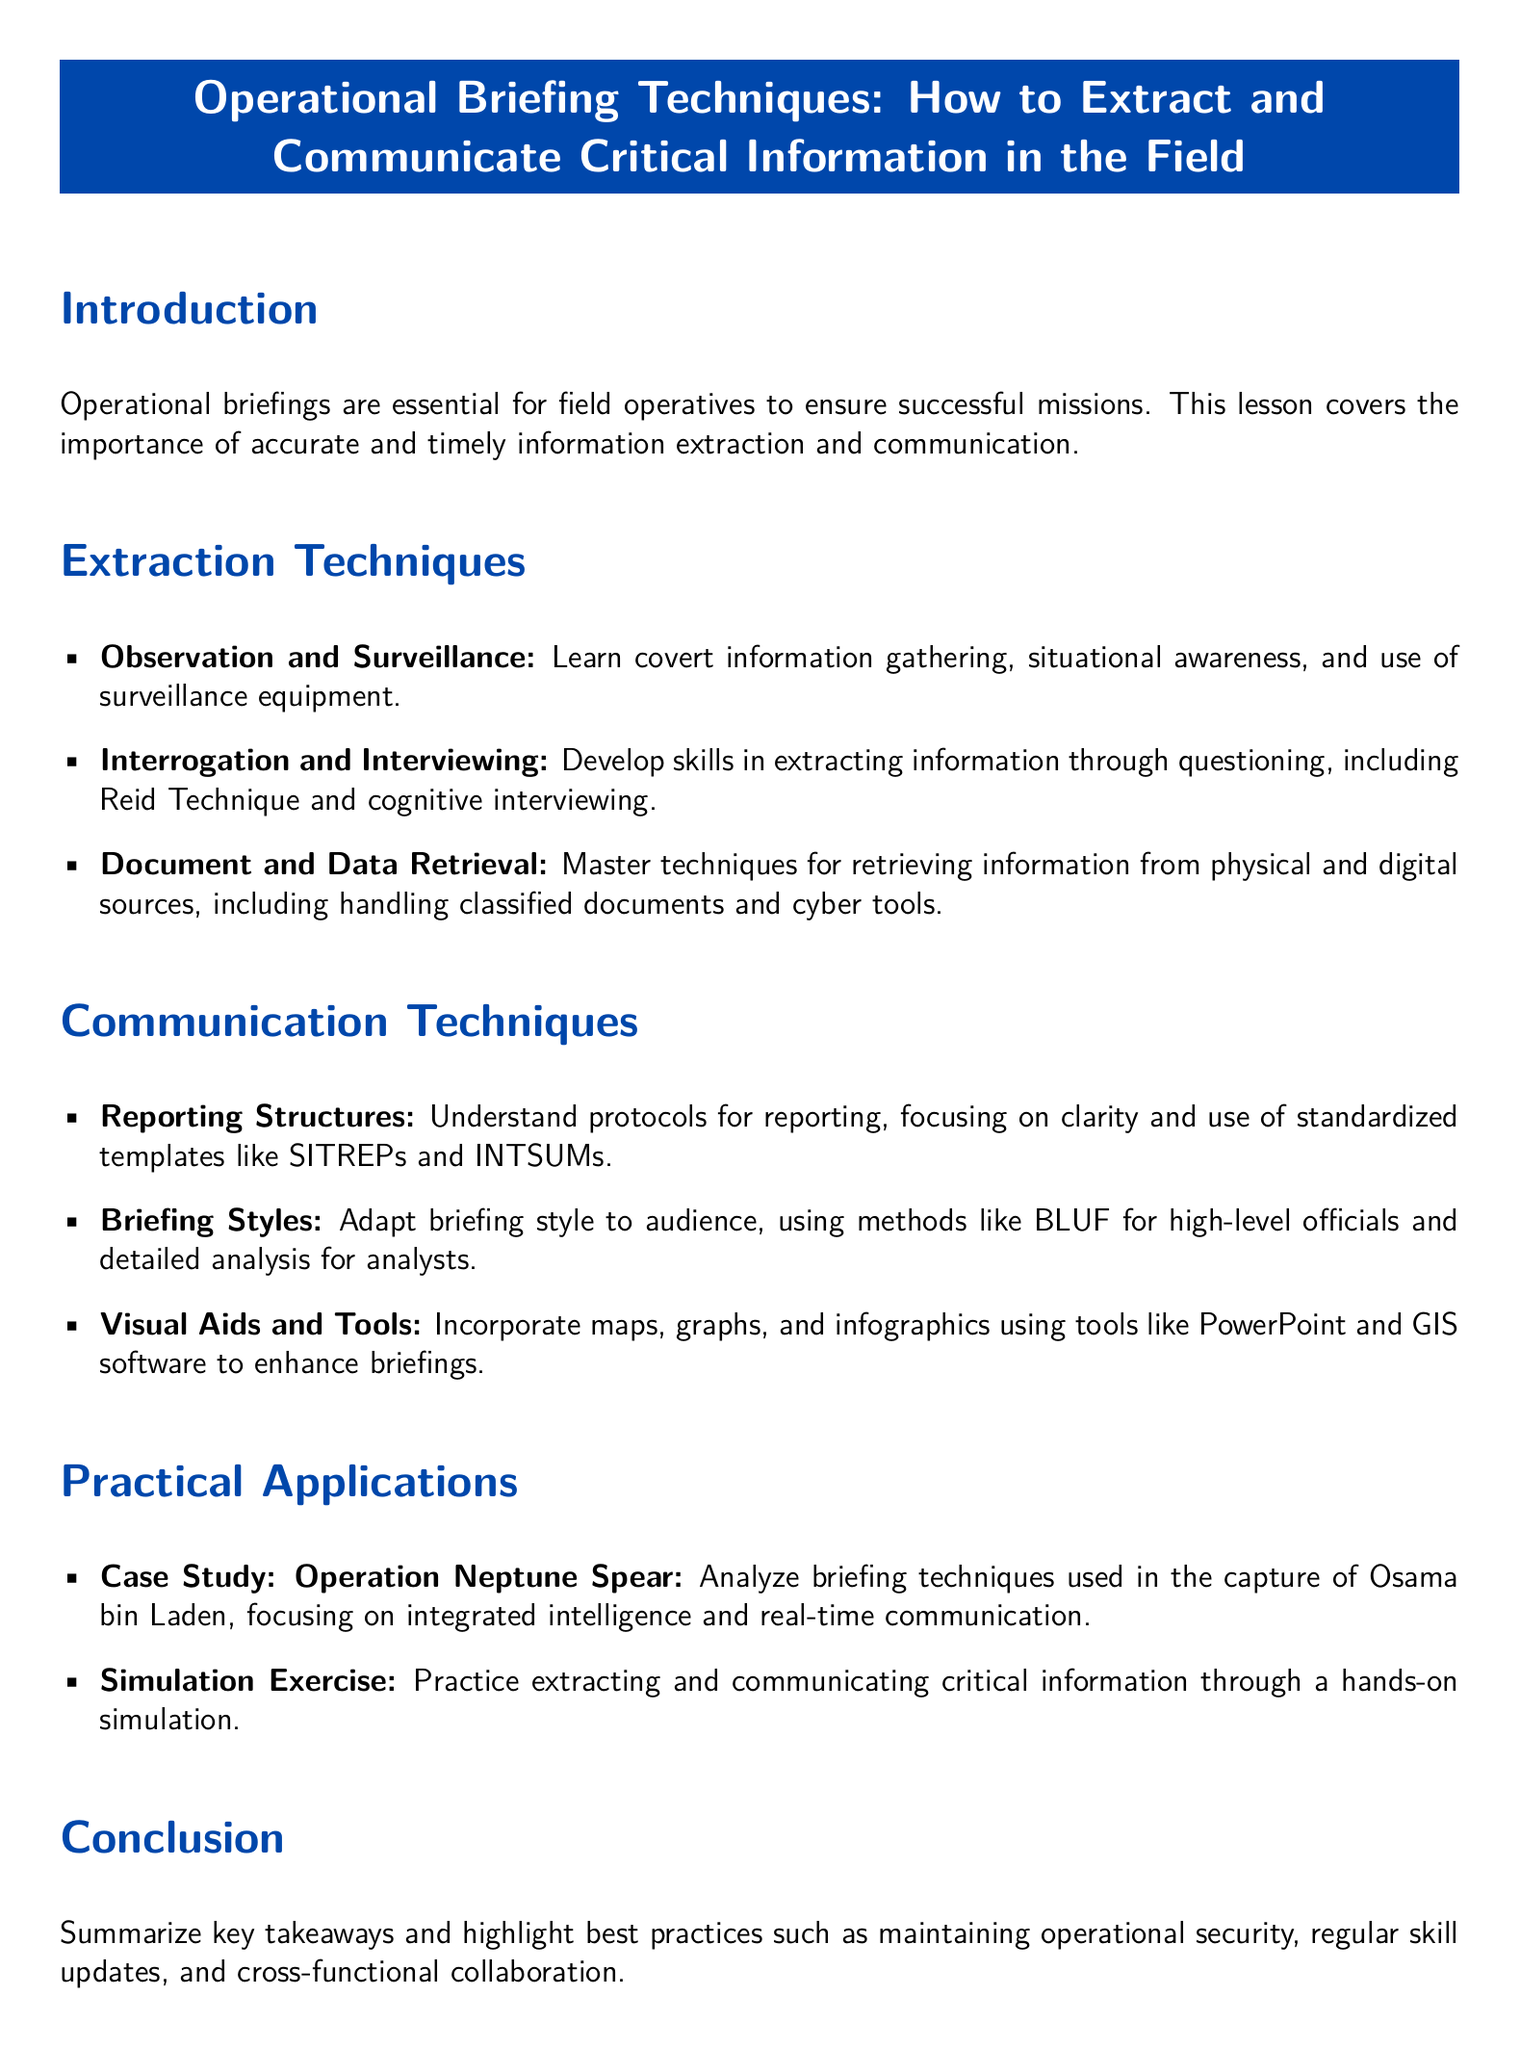What is the topic of the lesson plan? The topic of the lesson plan is clearly stated at the beginning of the document, which focuses on operational briefing techniques.
Answer: Operational Briefing Techniques: How to Extract and Communicate Critical Information in the Field What technique involves covert information gathering? This information can be found under the "Extraction Techniques" section, specifically listed as a bullet point.
Answer: Observation and Surveillance Which interviewing technique is mentioned in the document? The document lists specific techniques under "Interrogation and Interviewing," highlighting one of them explicitly.
Answer: Reid Technique What is the purpose of using reporting structures? The document mentions the purpose of reporting structures in the "Communication Techniques" section, focusing on clarity and templates.
Answer: Clarity What case study is analyzed in the lesson plan? The lesson plan mentions a specific case study that provides practical applications of the techniques taught.
Answer: Operation Neptune Spear What should be highlighted in the conclusion? The conclusion summarizes key takeaways and practices from the lesson, including what should always be maintained.
Answer: Operational security How should briefing styles be adapted? The document emphasizes adapting briefing styles to different audiences in the "Communication Techniques" section.
Answer: Audience What types of visual aids are suggested for enhancing briefings? Specific visual aids are mentioned in the "Communication Techniques" section to improve briefing effectiveness.
Answer: Maps, graphs, and infographics 